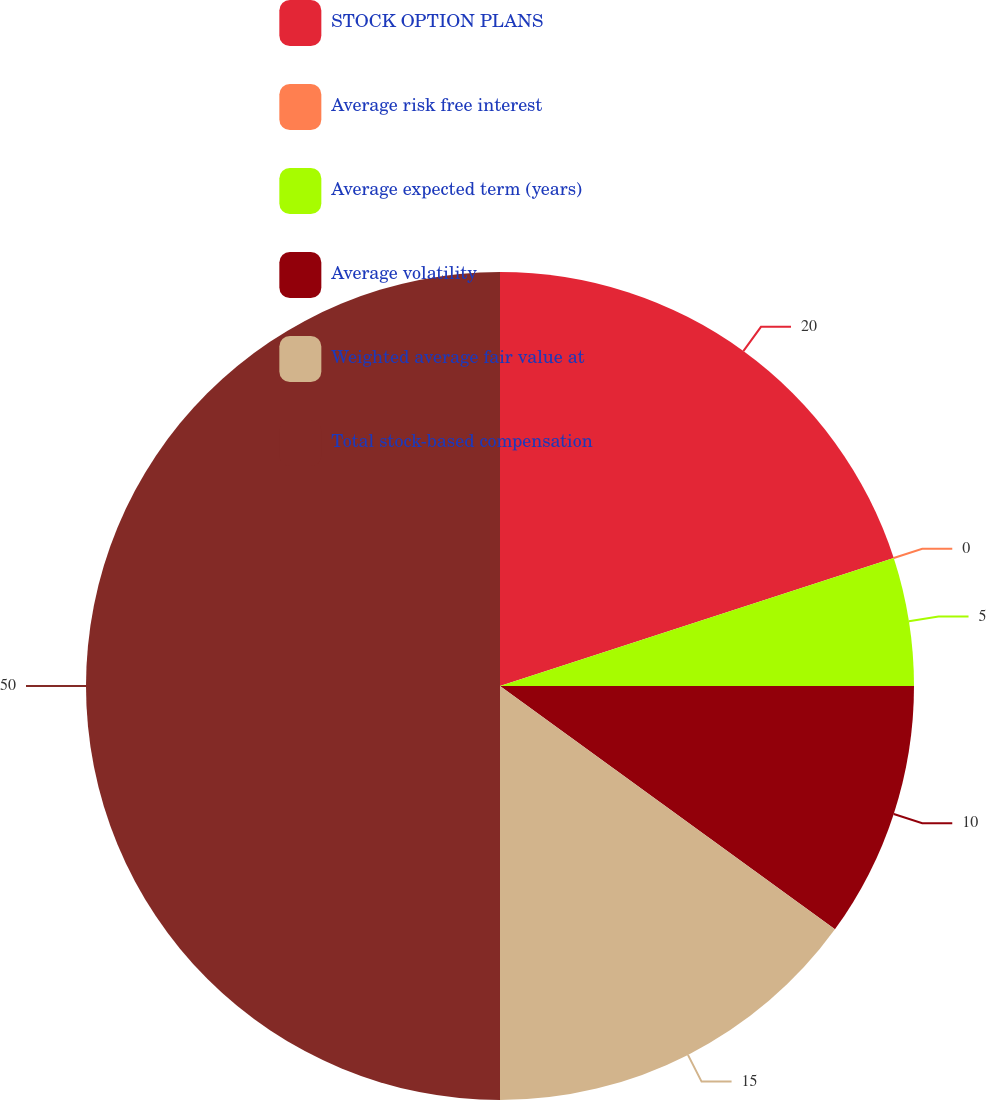<chart> <loc_0><loc_0><loc_500><loc_500><pie_chart><fcel>STOCK OPTION PLANS<fcel>Average risk free interest<fcel>Average expected term (years)<fcel>Average volatility<fcel>Weighted average fair value at<fcel>Total stock-based compensation<nl><fcel>20.0%<fcel>0.0%<fcel>5.0%<fcel>10.0%<fcel>15.0%<fcel>50.0%<nl></chart> 